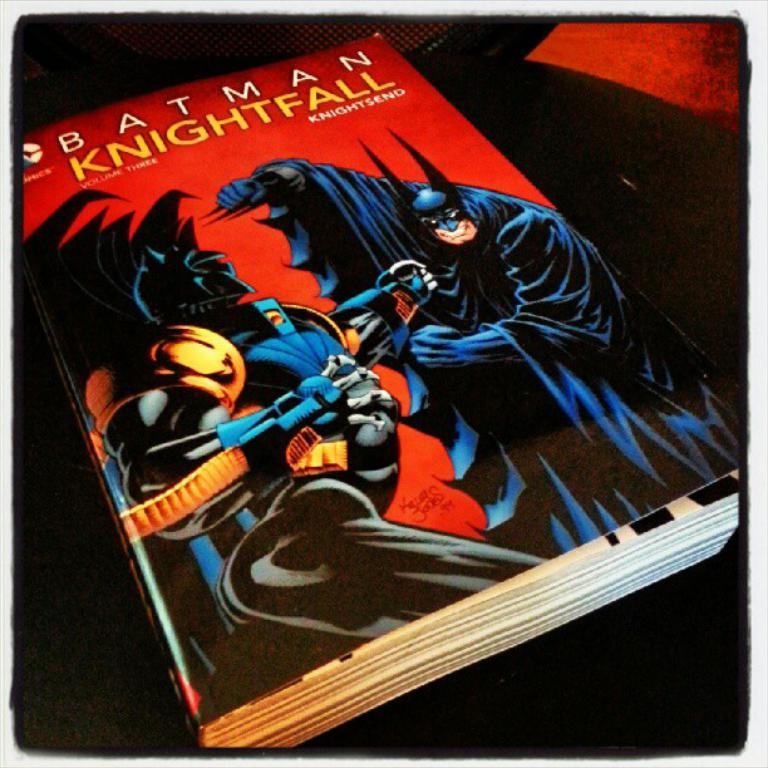Provide a one-sentence caption for the provided image. A Batman comic book titled Knightfall volume three. 